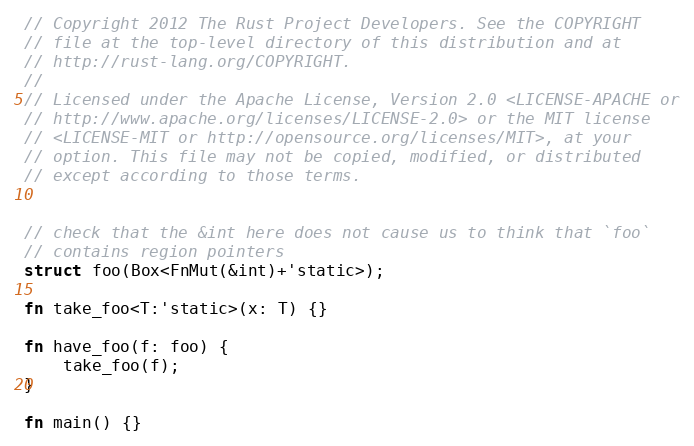<code> <loc_0><loc_0><loc_500><loc_500><_Rust_>// Copyright 2012 The Rust Project Developers. See the COPYRIGHT
// file at the top-level directory of this distribution and at
// http://rust-lang.org/COPYRIGHT.
//
// Licensed under the Apache License, Version 2.0 <LICENSE-APACHE or
// http://www.apache.org/licenses/LICENSE-2.0> or the MIT license
// <LICENSE-MIT or http://opensource.org/licenses/MIT>, at your
// option. This file may not be copied, modified, or distributed
// except according to those terms.


// check that the &int here does not cause us to think that `foo`
// contains region pointers
struct foo(Box<FnMut(&int)+'static>);

fn take_foo<T:'static>(x: T) {}

fn have_foo(f: foo) {
    take_foo(f);
}

fn main() {}
</code> 